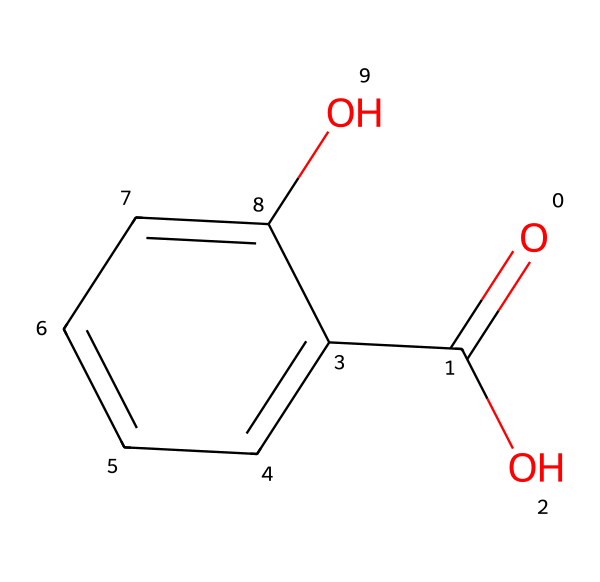what is the name of this chemical? The SMILES representation indicates a carboxylic acid group (O=C(O)) and a phenolic hydroxyl group (O) on a benzene ring (c1ccccc1). This structure corresponds to salicylic acid.
Answer: salicylic acid how many carbon atoms are in salicylic acid? Analyzing the structure, there are six carbon atoms in the benzene ring and one additional carbon in the carboxylic acid group, totaling seven carbon atoms.
Answer: seven how many oxygen atoms does this molecule contain? In the given structure, two oxygen atoms can be identified: one in the carboxylic acid group and one in the hydroxyl group attached to the benzene ring.
Answer: two which functional groups are present in this chemical? The structure showcases a carboxylic acid group (-COOH) and a hydroxyl group (-OH) attached to a benzene ring, making both functional groups present in salicylic acid.
Answer: carboxylic acid and hydroxyl group what properties make salicylic acid effective for scalp care? Salicylic acid's properties include its ability to exfoliate dead skin cells and reduce inflammation, which are beneficial for treating scalp conditions like dandruff and psoriasis.
Answer: exfoliation and anti-inflammatory how does the position of the hydroxyl group affect the activity of salicylic acid? The position of the hydroxyl group on the benzene ring increases solubility in water and contributes to the compound's ability to penetrate the skin, enhancing its effectiveness in formulations.
Answer: increases solubility and penetration why is salicylic acid classified as a fragrance ingredient? Salicylic acid is often used in fragrance formulations for its ability to provide a unique scent, along with its therapeutic benefits in hair care products, offering both fragrance and function.
Answer: unique scent and therapeutic benefits 